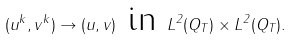<formula> <loc_0><loc_0><loc_500><loc_500>( u ^ { k } , v ^ { k } ) \to ( u , v ) \text { in } L ^ { 2 } ( Q _ { T } ) \times L ^ { 2 } ( Q _ { T } ) .</formula> 